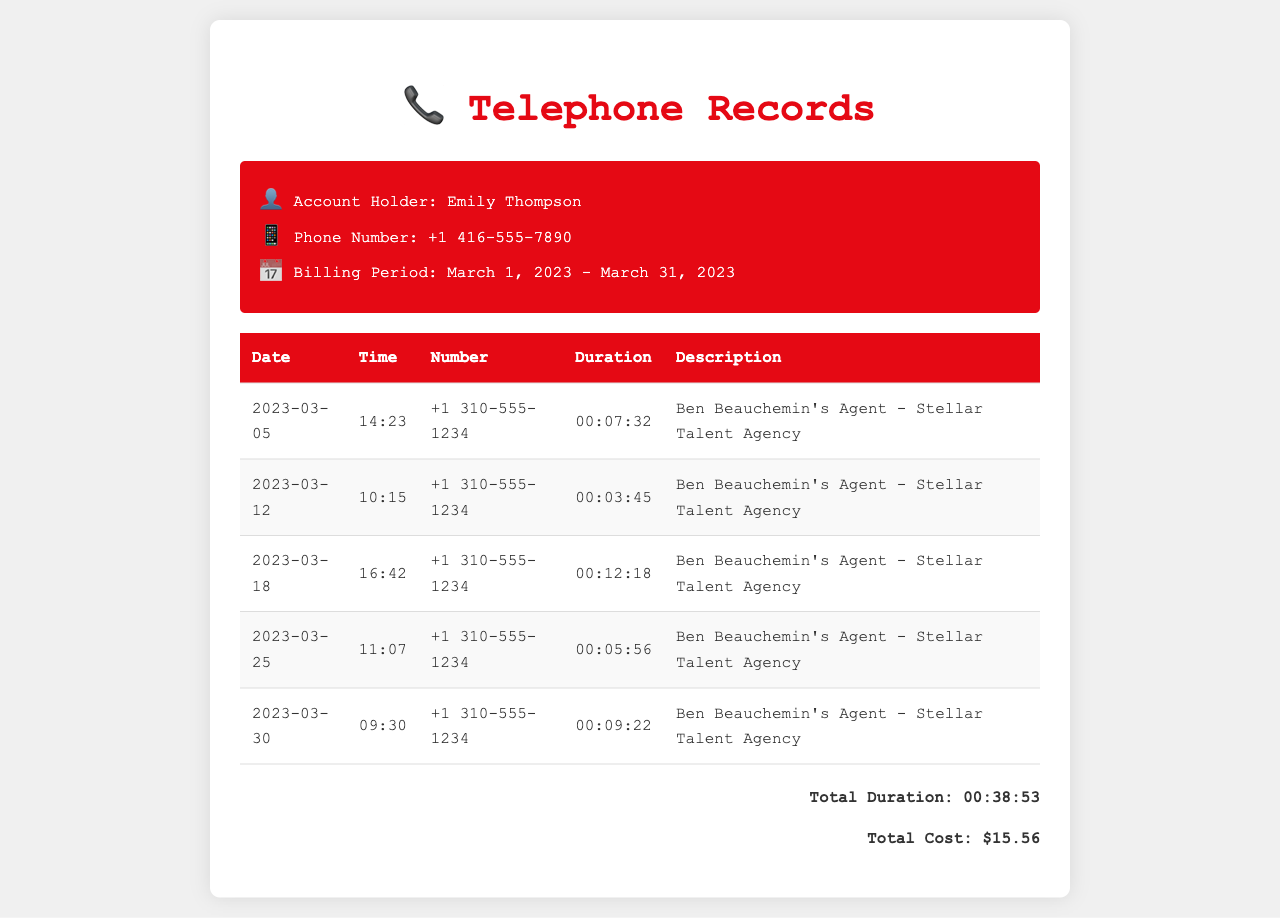What is the account holder's name? The account holder's name is mentioned at the top of the document in the header section.
Answer: Emily Thompson How many long-distance calls were made to Ben Beauchemin's agent? The number of calls can be counted from the rows in the table that list calls to Ben Beauchemin's agent.
Answer: 5 What was the total duration of the calls? The total duration is provided in the footer section of the document, summing up all call lengths.
Answer: 00:38:53 On what date was the longest call made? The longest call duration can be determined by comparing the durations of each call listed in the table.
Answer: 2023-03-18 What is the call duration of the call made on March 12, 2023? The call duration is specified in the table next to the corresponding date.
Answer: 00:03:45 What is the phone number for Ben Beauchemin's agent? The phone number appears consistently in the table for all calls made to the agent.
Answer: +1 310-555-1234 What is the total cost of the calls? The total cost is directly stated in the footer.
Answer: $15.56 At what time was the first call made to Ben Beauchemin's agent? The time is listed in the Time column of the first entry in the table.
Answer: 14:23 